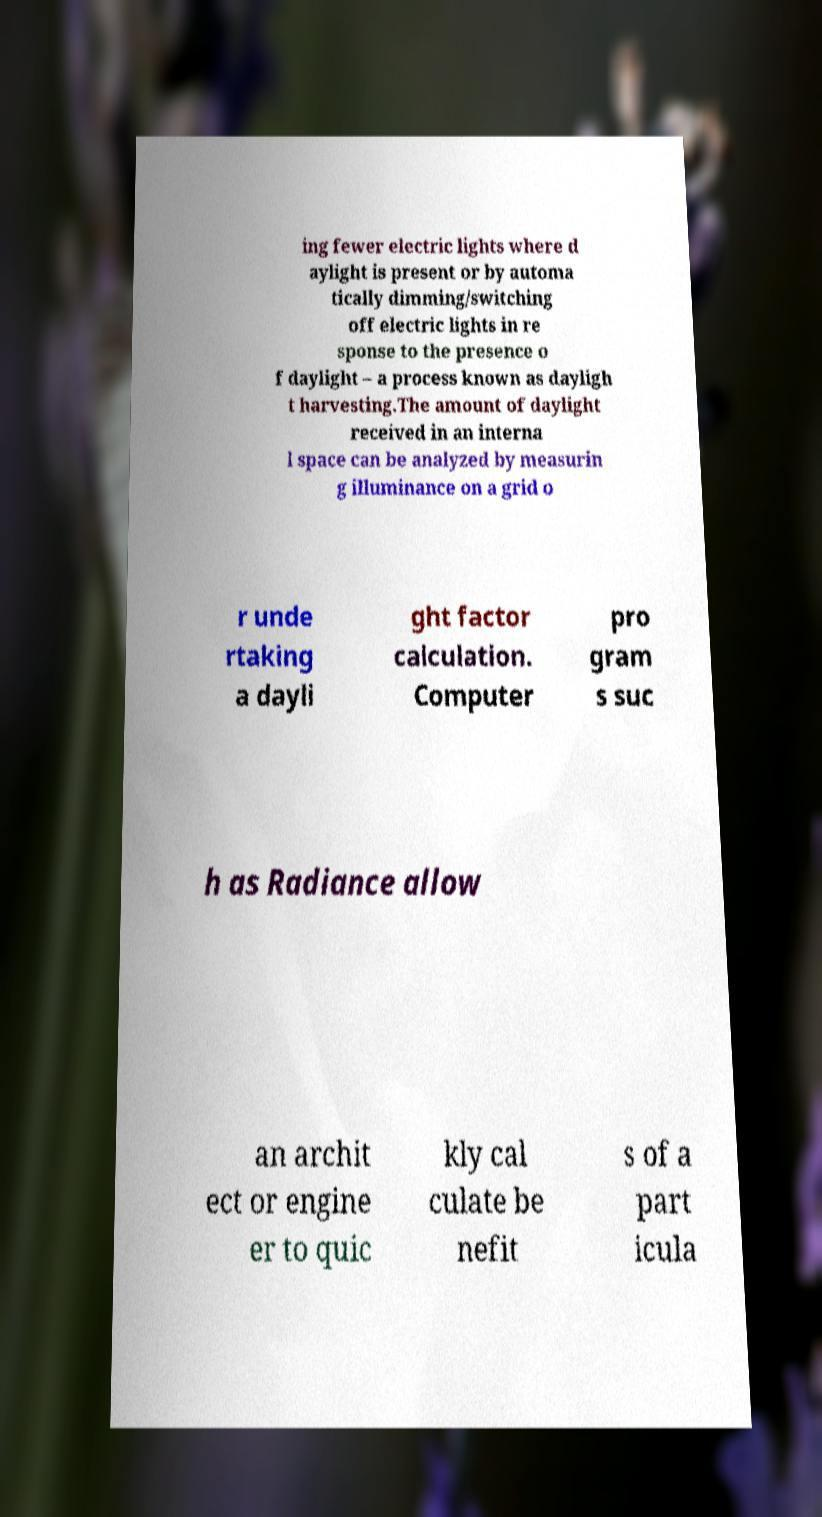There's text embedded in this image that I need extracted. Can you transcribe it verbatim? ing fewer electric lights where d aylight is present or by automa tically dimming/switching off electric lights in re sponse to the presence o f daylight – a process known as dayligh t harvesting.The amount of daylight received in an interna l space can be analyzed by measurin g illuminance on a grid o r unde rtaking a dayli ght factor calculation. Computer pro gram s suc h as Radiance allow an archit ect or engine er to quic kly cal culate be nefit s of a part icula 